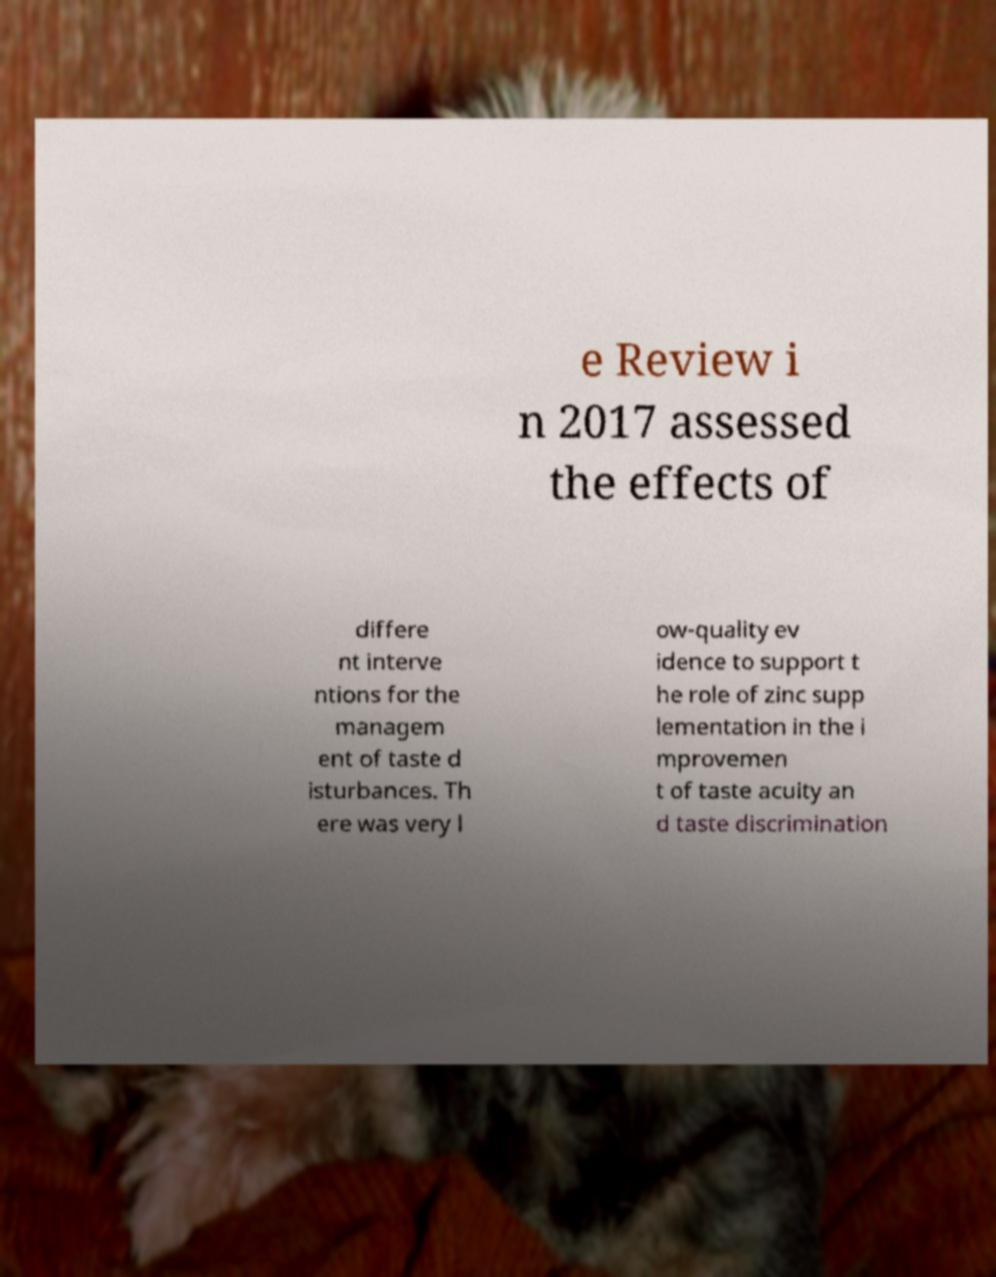Can you read and provide the text displayed in the image?This photo seems to have some interesting text. Can you extract and type it out for me? e Review i n 2017 assessed the effects of differe nt interve ntions for the managem ent of taste d isturbances. Th ere was very l ow-quality ev idence to support t he role of zinc supp lementation in the i mprovemen t of taste acuity an d taste discrimination 